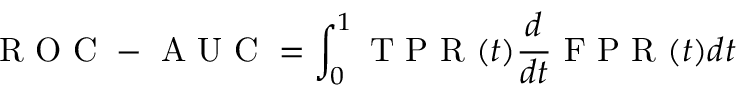Convert formula to latex. <formula><loc_0><loc_0><loc_500><loc_500>R O C - A U C = \int _ { 0 } ^ { 1 } T P R ( t ) \frac { d } { d t } F P R ( t ) d t</formula> 